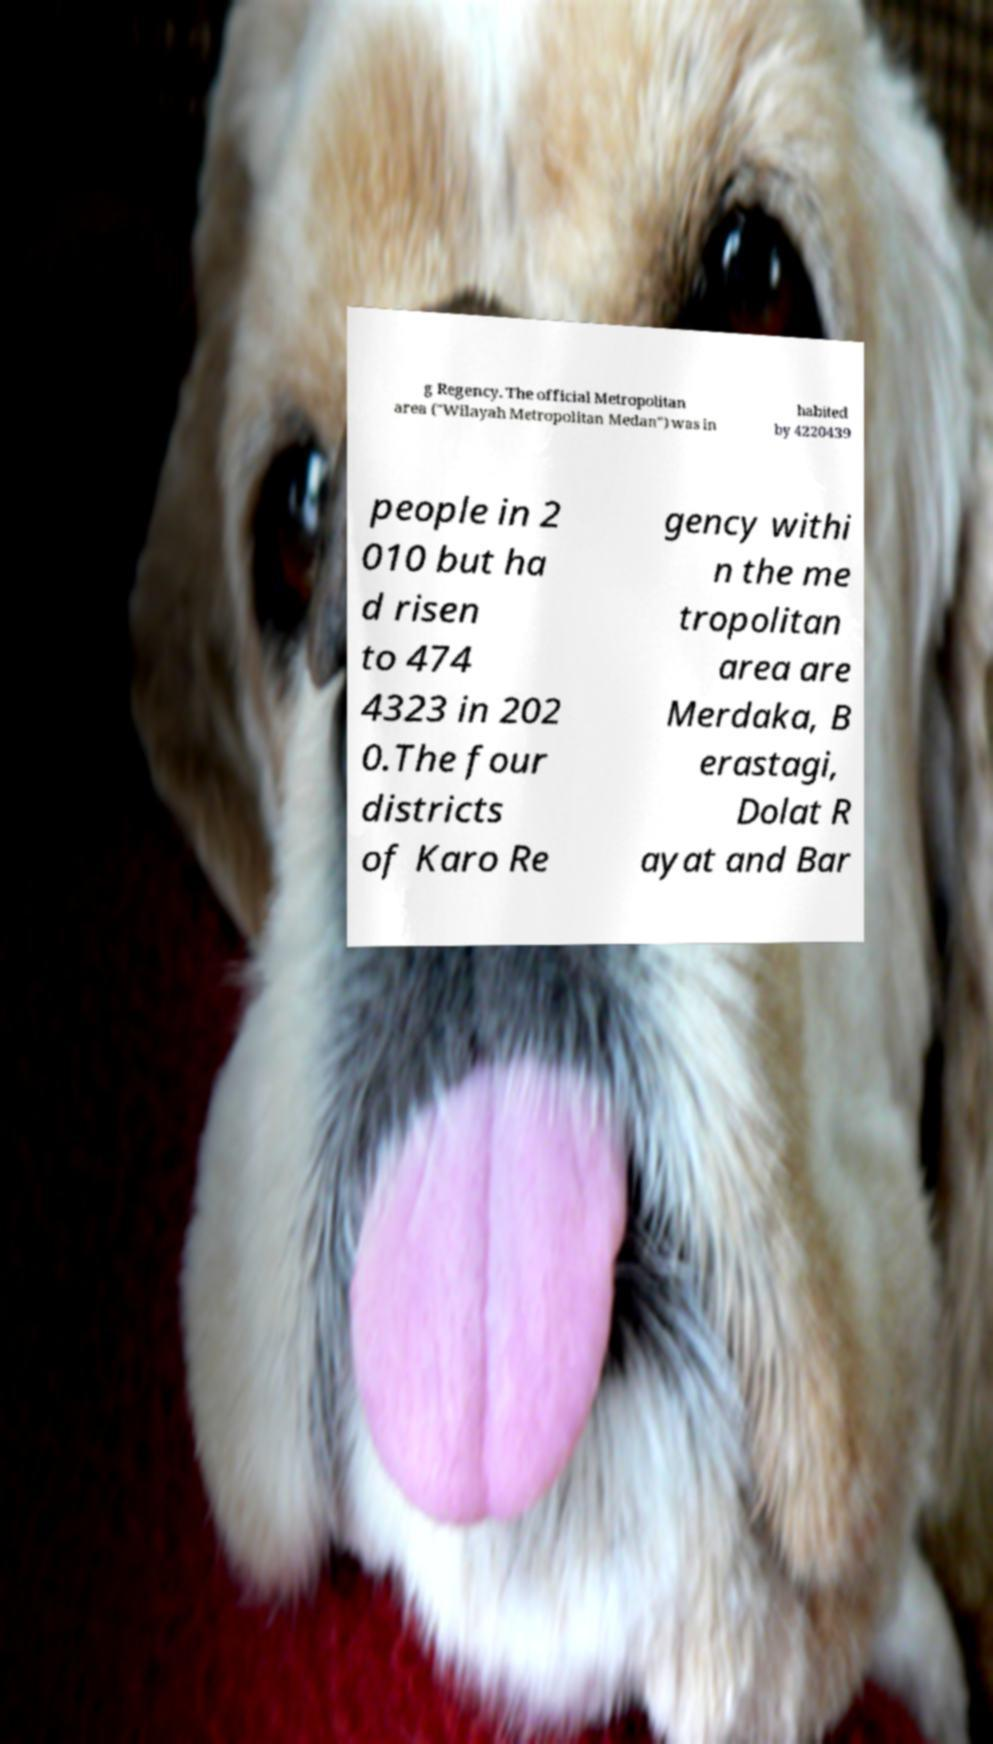I need the written content from this picture converted into text. Can you do that? g Regency. The official Metropolitan area ("Wilayah Metropolitan Medan") was in habited by 4220439 people in 2 010 but ha d risen to 474 4323 in 202 0.The four districts of Karo Re gency withi n the me tropolitan area are Merdaka, B erastagi, Dolat R ayat and Bar 